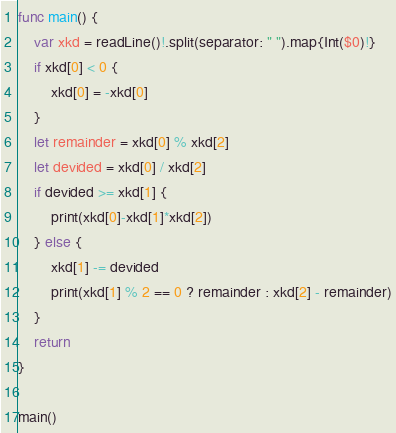<code> <loc_0><loc_0><loc_500><loc_500><_Swift_>func main() {
    var xkd = readLine()!.split(separator: " ").map{Int($0)!}
    if xkd[0] < 0 {
        xkd[0] = -xkd[0]
    }
    let remainder = xkd[0] % xkd[2]
    let devided = xkd[0] / xkd[2]
    if devided >= xkd[1] {
        print(xkd[0]-xkd[1]*xkd[2])
    } else {
        xkd[1] -= devided
        print(xkd[1] % 2 == 0 ? remainder : xkd[2] - remainder)
    }
    return
}

main()
</code> 